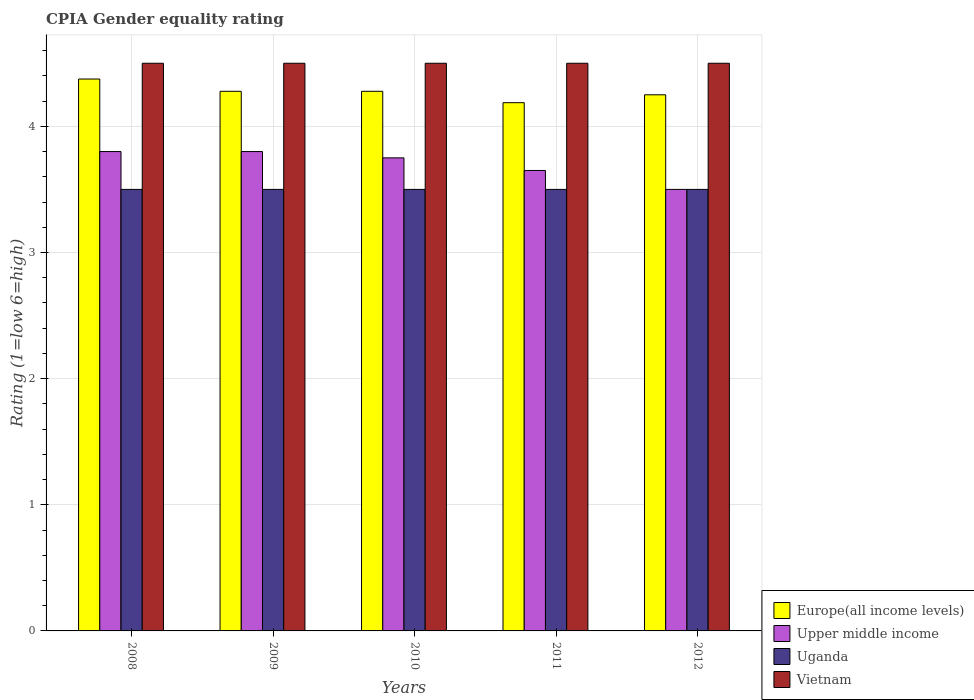How many different coloured bars are there?
Offer a very short reply. 4. Are the number of bars per tick equal to the number of legend labels?
Your answer should be compact. Yes. Are the number of bars on each tick of the X-axis equal?
Ensure brevity in your answer.  Yes. How many bars are there on the 5th tick from the left?
Offer a terse response. 4. What is the label of the 2nd group of bars from the left?
Give a very brief answer. 2009. In how many cases, is the number of bars for a given year not equal to the number of legend labels?
Ensure brevity in your answer.  0. What is the CPIA rating in Upper middle income in 2008?
Your answer should be compact. 3.8. Across all years, what is the maximum CPIA rating in Uganda?
Your answer should be compact. 3.5. Across all years, what is the minimum CPIA rating in Uganda?
Your response must be concise. 3.5. In which year was the CPIA rating in Uganda minimum?
Ensure brevity in your answer.  2008. What is the difference between the CPIA rating in Upper middle income in 2008 and that in 2011?
Offer a very short reply. 0.15. What is the difference between the CPIA rating in Vietnam in 2008 and the CPIA rating in Upper middle income in 2011?
Offer a terse response. 0.85. In the year 2011, what is the difference between the CPIA rating in Europe(all income levels) and CPIA rating in Upper middle income?
Offer a terse response. 0.54. In how many years, is the CPIA rating in Vietnam greater than 1.2?
Offer a very short reply. 5. What is the ratio of the CPIA rating in Europe(all income levels) in 2010 to that in 2012?
Ensure brevity in your answer.  1.01. What is the difference between the highest and the second highest CPIA rating in Upper middle income?
Make the answer very short. 0. What is the difference between the highest and the lowest CPIA rating in Upper middle income?
Offer a terse response. 0.3. What does the 1st bar from the left in 2012 represents?
Offer a very short reply. Europe(all income levels). What does the 2nd bar from the right in 2011 represents?
Offer a terse response. Uganda. Are all the bars in the graph horizontal?
Your answer should be compact. No. What is the difference between two consecutive major ticks on the Y-axis?
Offer a terse response. 1. Are the values on the major ticks of Y-axis written in scientific E-notation?
Provide a short and direct response. No. Where does the legend appear in the graph?
Keep it short and to the point. Bottom right. How many legend labels are there?
Provide a succinct answer. 4. How are the legend labels stacked?
Provide a short and direct response. Vertical. What is the title of the graph?
Provide a short and direct response. CPIA Gender equality rating. Does "Equatorial Guinea" appear as one of the legend labels in the graph?
Offer a terse response. No. What is the label or title of the X-axis?
Keep it short and to the point. Years. What is the label or title of the Y-axis?
Offer a very short reply. Rating (1=low 6=high). What is the Rating (1=low 6=high) in Europe(all income levels) in 2008?
Your answer should be compact. 4.38. What is the Rating (1=low 6=high) in Uganda in 2008?
Make the answer very short. 3.5. What is the Rating (1=low 6=high) of Europe(all income levels) in 2009?
Offer a terse response. 4.28. What is the Rating (1=low 6=high) of Vietnam in 2009?
Offer a very short reply. 4.5. What is the Rating (1=low 6=high) in Europe(all income levels) in 2010?
Provide a succinct answer. 4.28. What is the Rating (1=low 6=high) of Upper middle income in 2010?
Your response must be concise. 3.75. What is the Rating (1=low 6=high) in Vietnam in 2010?
Your response must be concise. 4.5. What is the Rating (1=low 6=high) of Europe(all income levels) in 2011?
Keep it short and to the point. 4.19. What is the Rating (1=low 6=high) of Upper middle income in 2011?
Your answer should be very brief. 3.65. What is the Rating (1=low 6=high) in Uganda in 2011?
Make the answer very short. 3.5. What is the Rating (1=low 6=high) of Vietnam in 2011?
Keep it short and to the point. 4.5. What is the Rating (1=low 6=high) of Europe(all income levels) in 2012?
Your answer should be compact. 4.25. What is the Rating (1=low 6=high) in Upper middle income in 2012?
Give a very brief answer. 3.5. What is the Rating (1=low 6=high) of Vietnam in 2012?
Make the answer very short. 4.5. Across all years, what is the maximum Rating (1=low 6=high) in Europe(all income levels)?
Your answer should be compact. 4.38. Across all years, what is the maximum Rating (1=low 6=high) of Upper middle income?
Offer a very short reply. 3.8. Across all years, what is the minimum Rating (1=low 6=high) of Europe(all income levels)?
Offer a very short reply. 4.19. Across all years, what is the minimum Rating (1=low 6=high) of Upper middle income?
Offer a terse response. 3.5. Across all years, what is the minimum Rating (1=low 6=high) in Vietnam?
Provide a succinct answer. 4.5. What is the total Rating (1=low 6=high) in Europe(all income levels) in the graph?
Give a very brief answer. 21.37. What is the total Rating (1=low 6=high) in Vietnam in the graph?
Your answer should be very brief. 22.5. What is the difference between the Rating (1=low 6=high) in Europe(all income levels) in 2008 and that in 2009?
Offer a very short reply. 0.1. What is the difference between the Rating (1=low 6=high) of Europe(all income levels) in 2008 and that in 2010?
Make the answer very short. 0.1. What is the difference between the Rating (1=low 6=high) in Upper middle income in 2008 and that in 2010?
Your response must be concise. 0.05. What is the difference between the Rating (1=low 6=high) of Vietnam in 2008 and that in 2010?
Your response must be concise. 0. What is the difference between the Rating (1=low 6=high) in Europe(all income levels) in 2008 and that in 2011?
Give a very brief answer. 0.19. What is the difference between the Rating (1=low 6=high) in Vietnam in 2008 and that in 2011?
Make the answer very short. 0. What is the difference between the Rating (1=low 6=high) of Europe(all income levels) in 2008 and that in 2012?
Provide a short and direct response. 0.12. What is the difference between the Rating (1=low 6=high) of Upper middle income in 2008 and that in 2012?
Provide a succinct answer. 0.3. What is the difference between the Rating (1=low 6=high) of Uganda in 2008 and that in 2012?
Offer a terse response. 0. What is the difference between the Rating (1=low 6=high) of Vietnam in 2009 and that in 2010?
Offer a terse response. 0. What is the difference between the Rating (1=low 6=high) in Europe(all income levels) in 2009 and that in 2011?
Provide a succinct answer. 0.09. What is the difference between the Rating (1=low 6=high) of Europe(all income levels) in 2009 and that in 2012?
Offer a very short reply. 0.03. What is the difference between the Rating (1=low 6=high) of Upper middle income in 2009 and that in 2012?
Ensure brevity in your answer.  0.3. What is the difference between the Rating (1=low 6=high) in Uganda in 2009 and that in 2012?
Provide a succinct answer. 0. What is the difference between the Rating (1=low 6=high) of Vietnam in 2009 and that in 2012?
Give a very brief answer. 0. What is the difference between the Rating (1=low 6=high) of Europe(all income levels) in 2010 and that in 2011?
Keep it short and to the point. 0.09. What is the difference between the Rating (1=low 6=high) of Uganda in 2010 and that in 2011?
Provide a succinct answer. 0. What is the difference between the Rating (1=low 6=high) in Europe(all income levels) in 2010 and that in 2012?
Make the answer very short. 0.03. What is the difference between the Rating (1=low 6=high) of Upper middle income in 2010 and that in 2012?
Provide a short and direct response. 0.25. What is the difference between the Rating (1=low 6=high) in Vietnam in 2010 and that in 2012?
Your answer should be very brief. 0. What is the difference between the Rating (1=low 6=high) of Europe(all income levels) in 2011 and that in 2012?
Provide a short and direct response. -0.06. What is the difference between the Rating (1=low 6=high) of Upper middle income in 2011 and that in 2012?
Give a very brief answer. 0.15. What is the difference between the Rating (1=low 6=high) of Uganda in 2011 and that in 2012?
Make the answer very short. 0. What is the difference between the Rating (1=low 6=high) of Europe(all income levels) in 2008 and the Rating (1=low 6=high) of Upper middle income in 2009?
Ensure brevity in your answer.  0.57. What is the difference between the Rating (1=low 6=high) of Europe(all income levels) in 2008 and the Rating (1=low 6=high) of Vietnam in 2009?
Your answer should be very brief. -0.12. What is the difference between the Rating (1=low 6=high) in Upper middle income in 2008 and the Rating (1=low 6=high) in Uganda in 2009?
Ensure brevity in your answer.  0.3. What is the difference between the Rating (1=low 6=high) in Uganda in 2008 and the Rating (1=low 6=high) in Vietnam in 2009?
Ensure brevity in your answer.  -1. What is the difference between the Rating (1=low 6=high) in Europe(all income levels) in 2008 and the Rating (1=low 6=high) in Upper middle income in 2010?
Make the answer very short. 0.62. What is the difference between the Rating (1=low 6=high) in Europe(all income levels) in 2008 and the Rating (1=low 6=high) in Uganda in 2010?
Make the answer very short. 0.88. What is the difference between the Rating (1=low 6=high) of Europe(all income levels) in 2008 and the Rating (1=low 6=high) of Vietnam in 2010?
Your answer should be very brief. -0.12. What is the difference between the Rating (1=low 6=high) in Upper middle income in 2008 and the Rating (1=low 6=high) in Vietnam in 2010?
Provide a short and direct response. -0.7. What is the difference between the Rating (1=low 6=high) in Uganda in 2008 and the Rating (1=low 6=high) in Vietnam in 2010?
Offer a very short reply. -1. What is the difference between the Rating (1=low 6=high) of Europe(all income levels) in 2008 and the Rating (1=low 6=high) of Upper middle income in 2011?
Your answer should be compact. 0.72. What is the difference between the Rating (1=low 6=high) of Europe(all income levels) in 2008 and the Rating (1=low 6=high) of Vietnam in 2011?
Your answer should be very brief. -0.12. What is the difference between the Rating (1=low 6=high) in Uganda in 2008 and the Rating (1=low 6=high) in Vietnam in 2011?
Give a very brief answer. -1. What is the difference between the Rating (1=low 6=high) of Europe(all income levels) in 2008 and the Rating (1=low 6=high) of Uganda in 2012?
Ensure brevity in your answer.  0.88. What is the difference between the Rating (1=low 6=high) of Europe(all income levels) in 2008 and the Rating (1=low 6=high) of Vietnam in 2012?
Your response must be concise. -0.12. What is the difference between the Rating (1=low 6=high) of Upper middle income in 2008 and the Rating (1=low 6=high) of Uganda in 2012?
Give a very brief answer. 0.3. What is the difference between the Rating (1=low 6=high) in Upper middle income in 2008 and the Rating (1=low 6=high) in Vietnam in 2012?
Give a very brief answer. -0.7. What is the difference between the Rating (1=low 6=high) in Uganda in 2008 and the Rating (1=low 6=high) in Vietnam in 2012?
Provide a short and direct response. -1. What is the difference between the Rating (1=low 6=high) in Europe(all income levels) in 2009 and the Rating (1=low 6=high) in Upper middle income in 2010?
Your answer should be very brief. 0.53. What is the difference between the Rating (1=low 6=high) of Europe(all income levels) in 2009 and the Rating (1=low 6=high) of Vietnam in 2010?
Give a very brief answer. -0.22. What is the difference between the Rating (1=low 6=high) of Upper middle income in 2009 and the Rating (1=low 6=high) of Vietnam in 2010?
Your answer should be compact. -0.7. What is the difference between the Rating (1=low 6=high) of Europe(all income levels) in 2009 and the Rating (1=low 6=high) of Upper middle income in 2011?
Make the answer very short. 0.63. What is the difference between the Rating (1=low 6=high) of Europe(all income levels) in 2009 and the Rating (1=low 6=high) of Uganda in 2011?
Your response must be concise. 0.78. What is the difference between the Rating (1=low 6=high) of Europe(all income levels) in 2009 and the Rating (1=low 6=high) of Vietnam in 2011?
Provide a short and direct response. -0.22. What is the difference between the Rating (1=low 6=high) in Upper middle income in 2009 and the Rating (1=low 6=high) in Vietnam in 2011?
Give a very brief answer. -0.7. What is the difference between the Rating (1=low 6=high) in Europe(all income levels) in 2009 and the Rating (1=low 6=high) in Upper middle income in 2012?
Ensure brevity in your answer.  0.78. What is the difference between the Rating (1=low 6=high) of Europe(all income levels) in 2009 and the Rating (1=low 6=high) of Vietnam in 2012?
Keep it short and to the point. -0.22. What is the difference between the Rating (1=low 6=high) in Upper middle income in 2009 and the Rating (1=low 6=high) in Uganda in 2012?
Your answer should be very brief. 0.3. What is the difference between the Rating (1=low 6=high) in Uganda in 2009 and the Rating (1=low 6=high) in Vietnam in 2012?
Your answer should be compact. -1. What is the difference between the Rating (1=low 6=high) of Europe(all income levels) in 2010 and the Rating (1=low 6=high) of Upper middle income in 2011?
Offer a terse response. 0.63. What is the difference between the Rating (1=low 6=high) in Europe(all income levels) in 2010 and the Rating (1=low 6=high) in Vietnam in 2011?
Your answer should be very brief. -0.22. What is the difference between the Rating (1=low 6=high) in Upper middle income in 2010 and the Rating (1=low 6=high) in Uganda in 2011?
Make the answer very short. 0.25. What is the difference between the Rating (1=low 6=high) of Upper middle income in 2010 and the Rating (1=low 6=high) of Vietnam in 2011?
Your answer should be very brief. -0.75. What is the difference between the Rating (1=low 6=high) of Uganda in 2010 and the Rating (1=low 6=high) of Vietnam in 2011?
Provide a succinct answer. -1. What is the difference between the Rating (1=low 6=high) of Europe(all income levels) in 2010 and the Rating (1=low 6=high) of Upper middle income in 2012?
Make the answer very short. 0.78. What is the difference between the Rating (1=low 6=high) of Europe(all income levels) in 2010 and the Rating (1=low 6=high) of Vietnam in 2012?
Offer a terse response. -0.22. What is the difference between the Rating (1=low 6=high) of Upper middle income in 2010 and the Rating (1=low 6=high) of Uganda in 2012?
Make the answer very short. 0.25. What is the difference between the Rating (1=low 6=high) of Upper middle income in 2010 and the Rating (1=low 6=high) of Vietnam in 2012?
Provide a succinct answer. -0.75. What is the difference between the Rating (1=low 6=high) in Europe(all income levels) in 2011 and the Rating (1=low 6=high) in Upper middle income in 2012?
Provide a short and direct response. 0.69. What is the difference between the Rating (1=low 6=high) in Europe(all income levels) in 2011 and the Rating (1=low 6=high) in Uganda in 2012?
Your answer should be very brief. 0.69. What is the difference between the Rating (1=low 6=high) of Europe(all income levels) in 2011 and the Rating (1=low 6=high) of Vietnam in 2012?
Offer a terse response. -0.31. What is the difference between the Rating (1=low 6=high) of Upper middle income in 2011 and the Rating (1=low 6=high) of Vietnam in 2012?
Keep it short and to the point. -0.85. What is the average Rating (1=low 6=high) of Europe(all income levels) per year?
Your answer should be compact. 4.27. What is the average Rating (1=low 6=high) of Upper middle income per year?
Make the answer very short. 3.7. What is the average Rating (1=low 6=high) of Uganda per year?
Keep it short and to the point. 3.5. What is the average Rating (1=low 6=high) of Vietnam per year?
Provide a short and direct response. 4.5. In the year 2008, what is the difference between the Rating (1=low 6=high) in Europe(all income levels) and Rating (1=low 6=high) in Upper middle income?
Your answer should be compact. 0.57. In the year 2008, what is the difference between the Rating (1=low 6=high) in Europe(all income levels) and Rating (1=low 6=high) in Vietnam?
Offer a very short reply. -0.12. In the year 2008, what is the difference between the Rating (1=low 6=high) in Upper middle income and Rating (1=low 6=high) in Uganda?
Offer a very short reply. 0.3. In the year 2008, what is the difference between the Rating (1=low 6=high) of Upper middle income and Rating (1=low 6=high) of Vietnam?
Offer a very short reply. -0.7. In the year 2008, what is the difference between the Rating (1=low 6=high) of Uganda and Rating (1=low 6=high) of Vietnam?
Offer a very short reply. -1. In the year 2009, what is the difference between the Rating (1=low 6=high) in Europe(all income levels) and Rating (1=low 6=high) in Upper middle income?
Ensure brevity in your answer.  0.48. In the year 2009, what is the difference between the Rating (1=low 6=high) of Europe(all income levels) and Rating (1=low 6=high) of Vietnam?
Give a very brief answer. -0.22. In the year 2010, what is the difference between the Rating (1=low 6=high) in Europe(all income levels) and Rating (1=low 6=high) in Upper middle income?
Ensure brevity in your answer.  0.53. In the year 2010, what is the difference between the Rating (1=low 6=high) of Europe(all income levels) and Rating (1=low 6=high) of Vietnam?
Your answer should be compact. -0.22. In the year 2010, what is the difference between the Rating (1=low 6=high) in Upper middle income and Rating (1=low 6=high) in Uganda?
Your answer should be very brief. 0.25. In the year 2010, what is the difference between the Rating (1=low 6=high) in Upper middle income and Rating (1=low 6=high) in Vietnam?
Offer a terse response. -0.75. In the year 2011, what is the difference between the Rating (1=low 6=high) of Europe(all income levels) and Rating (1=low 6=high) of Upper middle income?
Offer a terse response. 0.54. In the year 2011, what is the difference between the Rating (1=low 6=high) of Europe(all income levels) and Rating (1=low 6=high) of Uganda?
Your answer should be compact. 0.69. In the year 2011, what is the difference between the Rating (1=low 6=high) in Europe(all income levels) and Rating (1=low 6=high) in Vietnam?
Ensure brevity in your answer.  -0.31. In the year 2011, what is the difference between the Rating (1=low 6=high) in Upper middle income and Rating (1=low 6=high) in Vietnam?
Your response must be concise. -0.85. In the year 2012, what is the difference between the Rating (1=low 6=high) of Europe(all income levels) and Rating (1=low 6=high) of Upper middle income?
Offer a very short reply. 0.75. In the year 2012, what is the difference between the Rating (1=low 6=high) of Europe(all income levels) and Rating (1=low 6=high) of Uganda?
Provide a short and direct response. 0.75. In the year 2012, what is the difference between the Rating (1=low 6=high) in Upper middle income and Rating (1=low 6=high) in Uganda?
Ensure brevity in your answer.  0. What is the ratio of the Rating (1=low 6=high) in Europe(all income levels) in 2008 to that in 2009?
Your answer should be compact. 1.02. What is the ratio of the Rating (1=low 6=high) of Upper middle income in 2008 to that in 2009?
Provide a succinct answer. 1. What is the ratio of the Rating (1=low 6=high) of Uganda in 2008 to that in 2009?
Your answer should be very brief. 1. What is the ratio of the Rating (1=low 6=high) of Vietnam in 2008 to that in 2009?
Offer a very short reply. 1. What is the ratio of the Rating (1=low 6=high) of Europe(all income levels) in 2008 to that in 2010?
Your response must be concise. 1.02. What is the ratio of the Rating (1=low 6=high) in Upper middle income in 2008 to that in 2010?
Make the answer very short. 1.01. What is the ratio of the Rating (1=low 6=high) of Europe(all income levels) in 2008 to that in 2011?
Give a very brief answer. 1.04. What is the ratio of the Rating (1=low 6=high) in Upper middle income in 2008 to that in 2011?
Provide a succinct answer. 1.04. What is the ratio of the Rating (1=low 6=high) of Uganda in 2008 to that in 2011?
Your response must be concise. 1. What is the ratio of the Rating (1=low 6=high) in Europe(all income levels) in 2008 to that in 2012?
Keep it short and to the point. 1.03. What is the ratio of the Rating (1=low 6=high) of Upper middle income in 2008 to that in 2012?
Keep it short and to the point. 1.09. What is the ratio of the Rating (1=low 6=high) in Vietnam in 2008 to that in 2012?
Offer a terse response. 1. What is the ratio of the Rating (1=low 6=high) of Upper middle income in 2009 to that in 2010?
Your answer should be very brief. 1.01. What is the ratio of the Rating (1=low 6=high) in Uganda in 2009 to that in 2010?
Provide a succinct answer. 1. What is the ratio of the Rating (1=low 6=high) of Vietnam in 2009 to that in 2010?
Offer a terse response. 1. What is the ratio of the Rating (1=low 6=high) of Europe(all income levels) in 2009 to that in 2011?
Your answer should be compact. 1.02. What is the ratio of the Rating (1=low 6=high) of Upper middle income in 2009 to that in 2011?
Provide a short and direct response. 1.04. What is the ratio of the Rating (1=low 6=high) in Vietnam in 2009 to that in 2011?
Offer a terse response. 1. What is the ratio of the Rating (1=low 6=high) of Upper middle income in 2009 to that in 2012?
Offer a very short reply. 1.09. What is the ratio of the Rating (1=low 6=high) of Uganda in 2009 to that in 2012?
Your answer should be very brief. 1. What is the ratio of the Rating (1=low 6=high) of Europe(all income levels) in 2010 to that in 2011?
Your response must be concise. 1.02. What is the ratio of the Rating (1=low 6=high) of Upper middle income in 2010 to that in 2011?
Your response must be concise. 1.03. What is the ratio of the Rating (1=low 6=high) of Europe(all income levels) in 2010 to that in 2012?
Keep it short and to the point. 1.01. What is the ratio of the Rating (1=low 6=high) of Upper middle income in 2010 to that in 2012?
Ensure brevity in your answer.  1.07. What is the ratio of the Rating (1=low 6=high) in Vietnam in 2010 to that in 2012?
Provide a succinct answer. 1. What is the ratio of the Rating (1=low 6=high) in Europe(all income levels) in 2011 to that in 2012?
Your answer should be very brief. 0.99. What is the ratio of the Rating (1=low 6=high) in Upper middle income in 2011 to that in 2012?
Ensure brevity in your answer.  1.04. What is the ratio of the Rating (1=low 6=high) of Uganda in 2011 to that in 2012?
Your response must be concise. 1. What is the ratio of the Rating (1=low 6=high) of Vietnam in 2011 to that in 2012?
Keep it short and to the point. 1. What is the difference between the highest and the second highest Rating (1=low 6=high) of Europe(all income levels)?
Your answer should be compact. 0.1. What is the difference between the highest and the second highest Rating (1=low 6=high) of Uganda?
Your answer should be compact. 0. What is the difference between the highest and the second highest Rating (1=low 6=high) of Vietnam?
Your response must be concise. 0. What is the difference between the highest and the lowest Rating (1=low 6=high) in Europe(all income levels)?
Provide a short and direct response. 0.19. What is the difference between the highest and the lowest Rating (1=low 6=high) in Upper middle income?
Provide a succinct answer. 0.3. What is the difference between the highest and the lowest Rating (1=low 6=high) of Vietnam?
Make the answer very short. 0. 